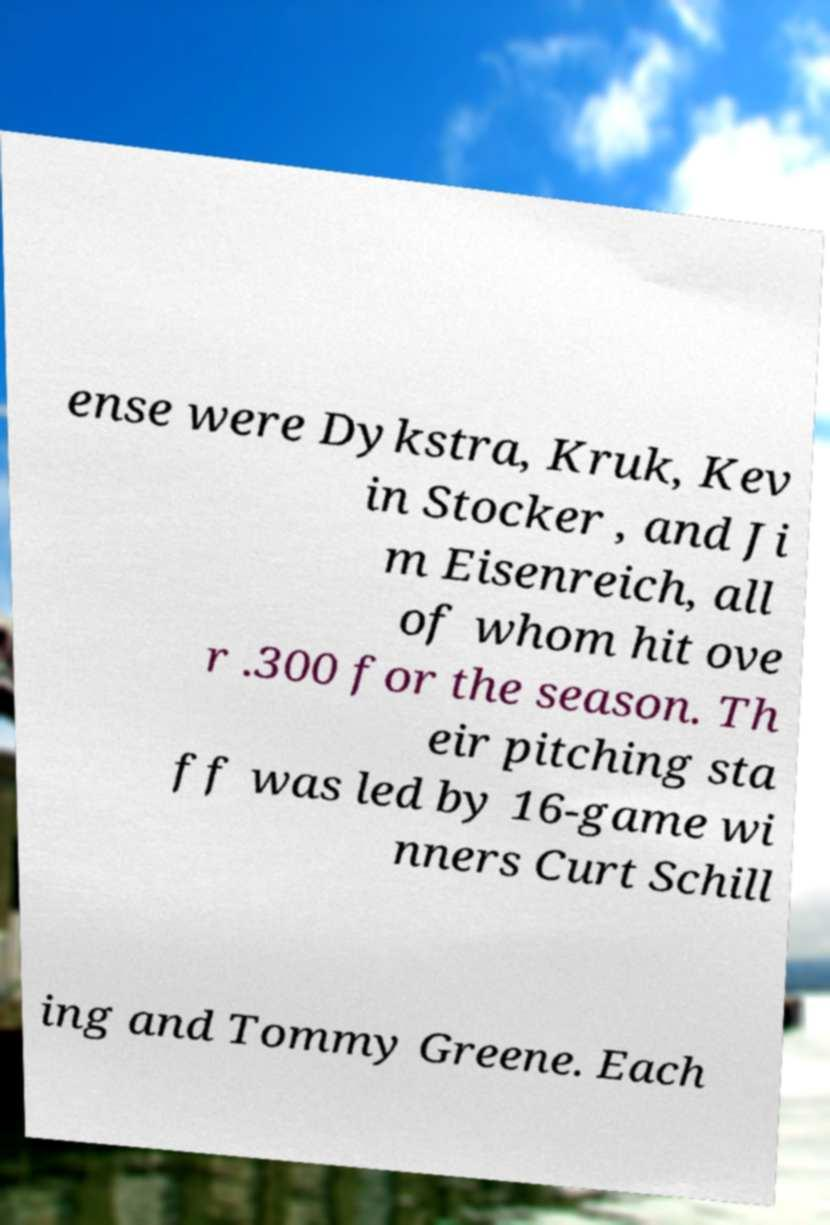I need the written content from this picture converted into text. Can you do that? ense were Dykstra, Kruk, Kev in Stocker , and Ji m Eisenreich, all of whom hit ove r .300 for the season. Th eir pitching sta ff was led by 16-game wi nners Curt Schill ing and Tommy Greene. Each 